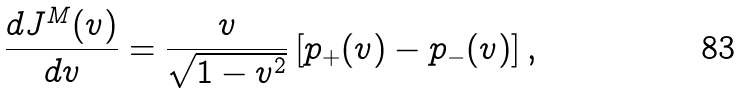Convert formula to latex. <formula><loc_0><loc_0><loc_500><loc_500>\frac { d J ^ { M } ( v ) } { d v } = \frac { v } { \sqrt { 1 - v ^ { 2 } } } \left [ p _ { + } ( v ) - p _ { - } ( v ) \right ] ,</formula> 